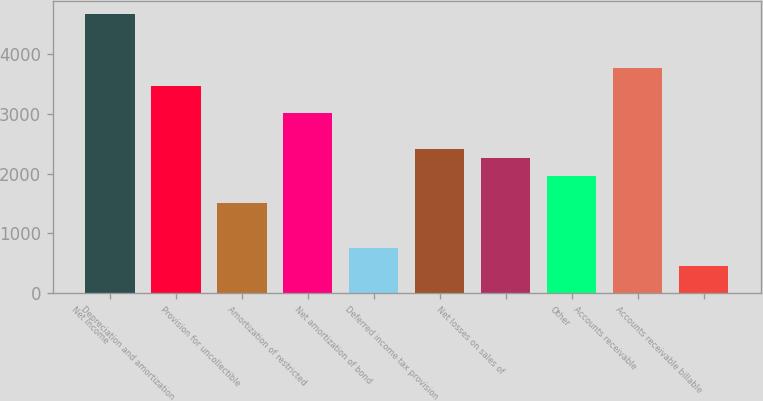Convert chart. <chart><loc_0><loc_0><loc_500><loc_500><bar_chart><fcel>Net income<fcel>Depreciation and amortization<fcel>Provision for uncollectible<fcel>Amortization of restricted<fcel>Net amortization of bond<fcel>Deferred income tax provision<fcel>Net losses on sales of<fcel>Other<fcel>Accounts receivable<fcel>Accounts receivable billable<nl><fcel>4667.86<fcel>3463.38<fcel>1506.1<fcel>3011.7<fcel>753.3<fcel>2409.46<fcel>2258.9<fcel>1957.78<fcel>3764.5<fcel>452.18<nl></chart> 